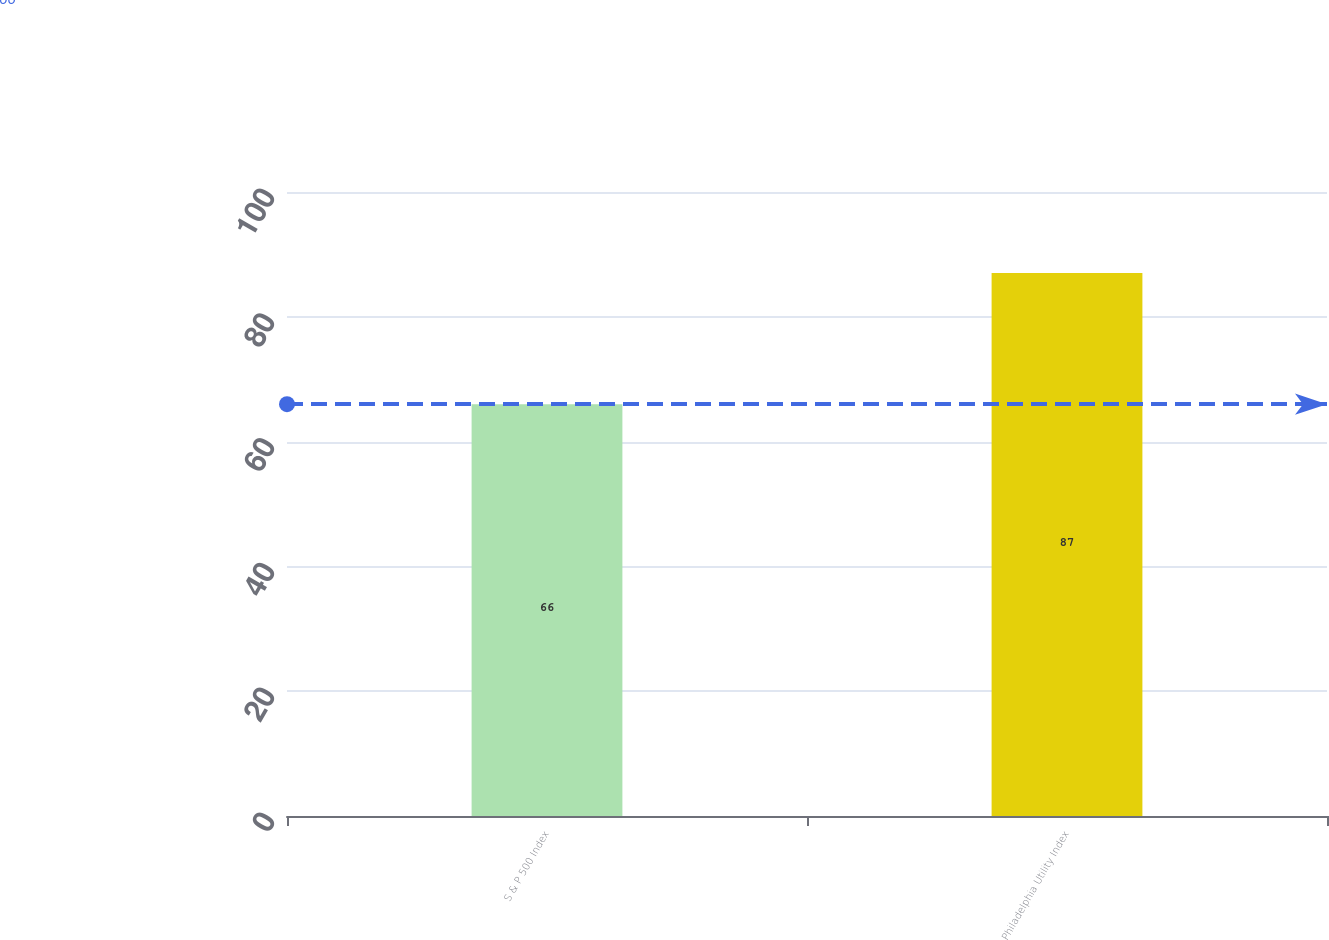Convert chart. <chart><loc_0><loc_0><loc_500><loc_500><bar_chart><fcel>S & P 500 Index<fcel>Philadelphia Utility Index<nl><fcel>66<fcel>87<nl></chart> 